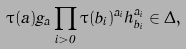Convert formula to latex. <formula><loc_0><loc_0><loc_500><loc_500>\tau ( a ) g _ { a } \prod _ { i > 0 } \tau ( b _ { i } ) ^ { a _ { i } } h _ { b _ { i } } ^ { a _ { i } } \in \Delta ,</formula> 